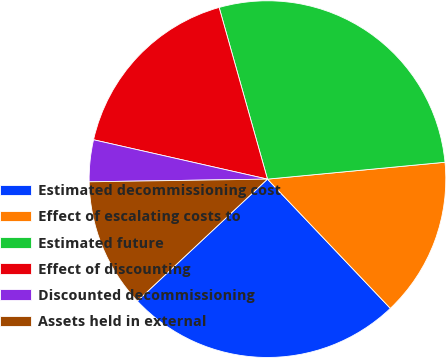Convert chart. <chart><loc_0><loc_0><loc_500><loc_500><pie_chart><fcel>Estimated decommissioning cost<fcel>Effect of escalating costs to<fcel>Estimated future<fcel>Effect of discounting<fcel>Discounted decommissioning<fcel>Assets held in external<nl><fcel>25.12%<fcel>14.41%<fcel>27.86%<fcel>17.09%<fcel>3.78%<fcel>11.74%<nl></chart> 